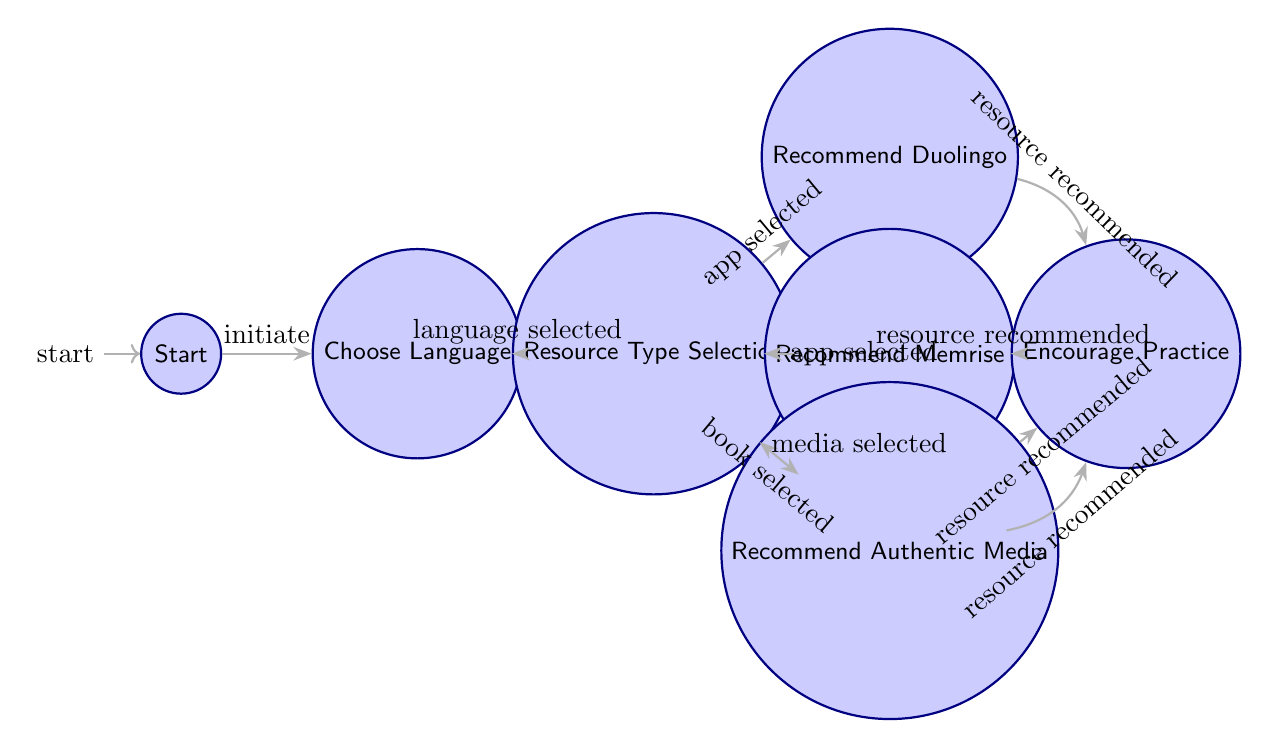What is the initial state of the diagram? The initial state is "Start," which is the first node in the flow of the diagram. It signifies the beginning of the recommendation process.
Answer: Start How many total states are present in the diagram? The diagram contains a total of 8 states: Start, Choose Language, Resource Type Selection, Recommend Duolingo, Recommend Memrise, Recommend Assimil, Recommend Authentic Media, and Encourage Practice.
Answer: 8 What are the two resource recommendations for app-based learning? The two resources recommended for app-based learning are Duolingo and Memrise, both of which follow the selection for app types in the resource type selection state.
Answer: Duolingo, Memrise Which state follows after selecting a media-based resource? After selecting a media-based resource, the next state is "Recommend Authentic Media," which is reached when the user chooses the option for media.
Answer: Recommend Authentic Media What is the final state of the recommendations? The final state where all paths converge after a resource has been recommended is "Encourage Practice." This state encourages the user to practice speaking with others.
Answer: Encourage Practice If a user selects a book-based resource, which recommendation do they receive? If the user selects a book-based resource, they transition to the state "Recommend Assimil," which specifically focuses on book-based language learning options.
Answer: Recommend Assimil What triggers the transition from "resource type selection" to "recommend duolingo"? The transition from "Resource Type Selection" to "Recommend Duolingo" is triggered by the selection of the app type, indicating the user's preference for an app-based resource.
Answer: App selected How many transitions are there from the "recommend memrise" state to the next state? There is only one transition from the "Recommend Memrise" state to the "Encourage Practice" state, which occurs after the resource has been recommended.
Answer: 1 What action must a user take to reach the resource recommendation states? To reach the resource recommendation states, the user must select a language after the initial selection state has been reached. This takes them to "Resource Type Selection" and subsequently to the recommendations.
Answer: Language selected 